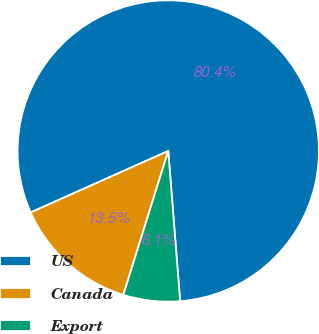<chart> <loc_0><loc_0><loc_500><loc_500><pie_chart><fcel>US<fcel>Canada<fcel>Export<nl><fcel>80.43%<fcel>13.5%<fcel>6.07%<nl></chart> 